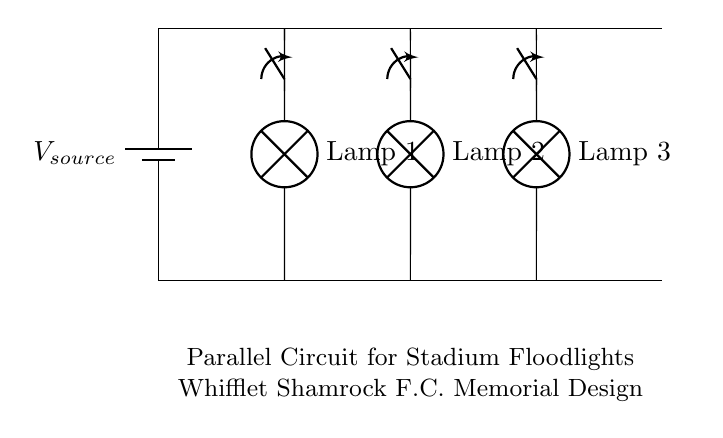What type of circuit is shown? This circuit is a parallel circuit, which can be determined by looking at how the lamps are connected. Each lamp has its own path to the voltage source, which is characteristic of a parallel configuration.
Answer: Parallel How many lamps are connected to the circuit? There are three lamps shown in the circuit diagram. Each lamp is depicted with a labeled symbol, and they are positioned along the same horizontal level, which indicates their individual connections to the circuit.
Answer: Three What is the purpose of the switches in this circuit? The switches are used to control the flow of electricity to each lamp. By opening or closing the switch above each lamp, you can turn the lamp on or off independently, a feature essential in a parallel circuit to allow selective control.
Answer: Control What is the main advantage of using a parallel circuit for floodlights? The main advantage of a parallel circuit is that if one lamp fails, the others continue to function. This is due to each lamp having its own separate pathway to the power source. If one pathway is disrupted, it does not affect the others.
Answer: Reliability What would happen if the switch for Lamp 2 is opened? If the switch for Lamp 2 is opened, Lamp 2 would turn off while the other lamps remain lit. This demonstrates how parallel connections allow lamps to operate independently, meaning the failure or control of one does not impact the entire circuit.
Answer: Lamp 2 off What could be inferred about the voltage across each lamp? Each lamp experiences the same voltage as the source. In a parallel circuit, the voltage across each component is equal to the source voltage, indicating that each lamp would receive the full power available from the power source.
Answer: Equal to source voltage What does the label on the circuit indicate? The label indicates that this is a memorial design for Whifflet Shamrock F.C., suggesting that the circuit was created in honor of the club, and it contextualizes the purpose of the floodlights in relation to the team's activities.
Answer: Memorial design 